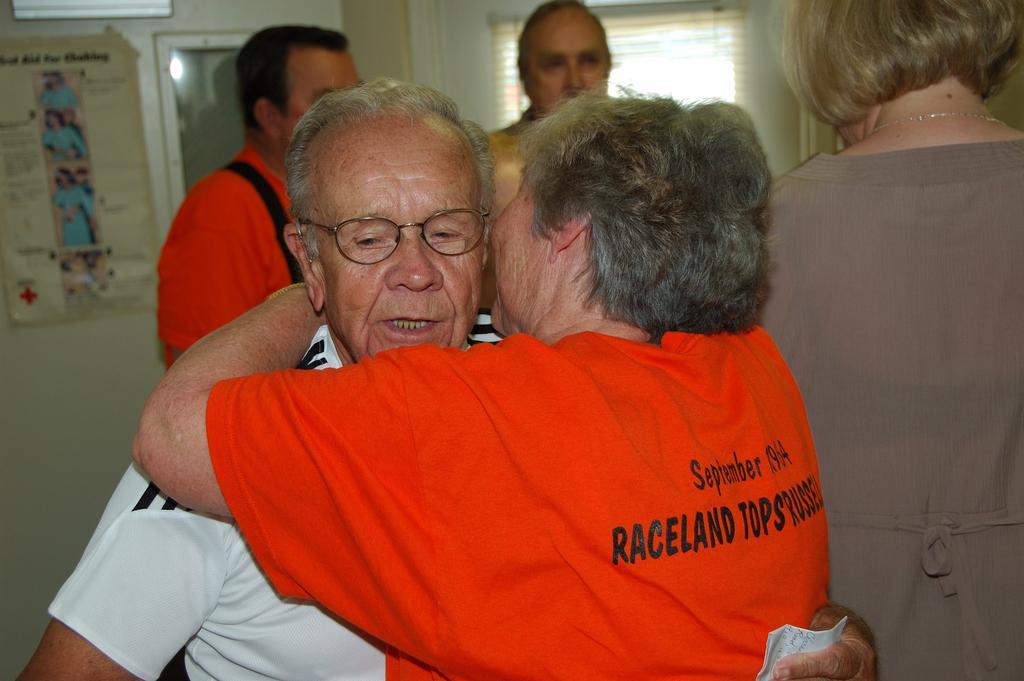Please provide a concise description of this image. In this picture we can see a group of people and in the background we can see a wall, poster and some objects. 